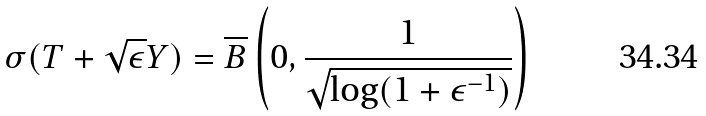Convert formula to latex. <formula><loc_0><loc_0><loc_500><loc_500>\sigma ( T + \sqrt { \epsilon } Y ) = \overline { B } \left ( 0 , \frac { 1 } { \sqrt { \log ( 1 + \epsilon ^ { - 1 } ) } } \right )</formula> 